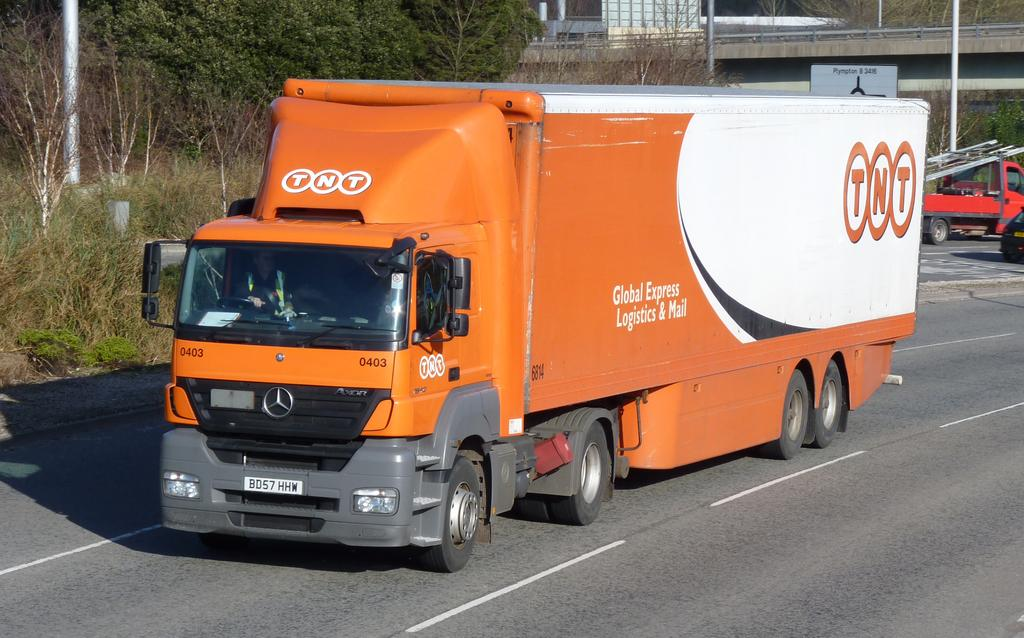What can be seen on the road in the image? There are vehicles on the road in the image. What type of natural elements are visible in the background of the image? There are trees in the background of the image. What man-made structures can be seen in the background of the image? There are poles and a bridge in the background of the image. What additional object is present in the background of the image? There is a board in the background of the image. Can you touch the bread in the image? There is no bread present in the image, so it cannot be touched. What type of cannon is visible in the image? There is no cannon present in the image. 